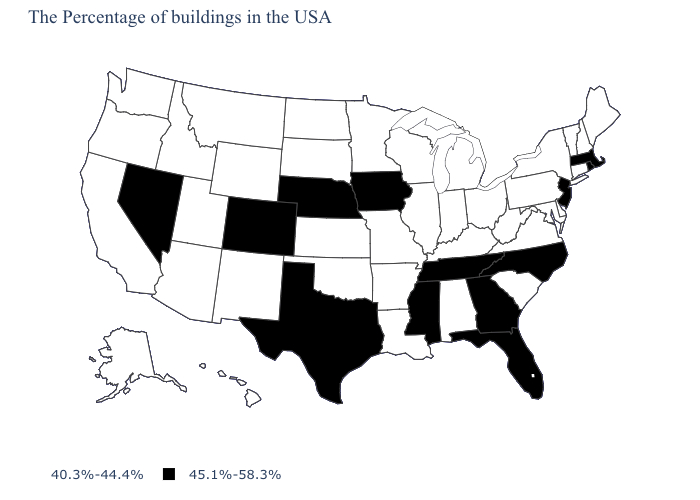Does Connecticut have the same value as New Mexico?
Write a very short answer. Yes. Name the states that have a value in the range 45.1%-58.3%?
Be succinct. Massachusetts, Rhode Island, New Jersey, North Carolina, Florida, Georgia, Tennessee, Mississippi, Iowa, Nebraska, Texas, Colorado, Nevada. What is the value of New York?
Answer briefly. 40.3%-44.4%. What is the value of Kentucky?
Concise answer only. 40.3%-44.4%. What is the highest value in states that border Montana?
Be succinct. 40.3%-44.4%. What is the value of Tennessee?
Keep it brief. 45.1%-58.3%. How many symbols are there in the legend?
Quick response, please. 2. What is the lowest value in states that border Maine?
Short answer required. 40.3%-44.4%. What is the value of Kentucky?
Concise answer only. 40.3%-44.4%. Does Tennessee have the lowest value in the USA?
Be succinct. No. Name the states that have a value in the range 45.1%-58.3%?
Be succinct. Massachusetts, Rhode Island, New Jersey, North Carolina, Florida, Georgia, Tennessee, Mississippi, Iowa, Nebraska, Texas, Colorado, Nevada. Does Kansas have a higher value than Nevada?
Write a very short answer. No. What is the value of Wisconsin?
Quick response, please. 40.3%-44.4%. Name the states that have a value in the range 45.1%-58.3%?
Write a very short answer. Massachusetts, Rhode Island, New Jersey, North Carolina, Florida, Georgia, Tennessee, Mississippi, Iowa, Nebraska, Texas, Colorado, Nevada. Does the first symbol in the legend represent the smallest category?
Keep it brief. Yes. 